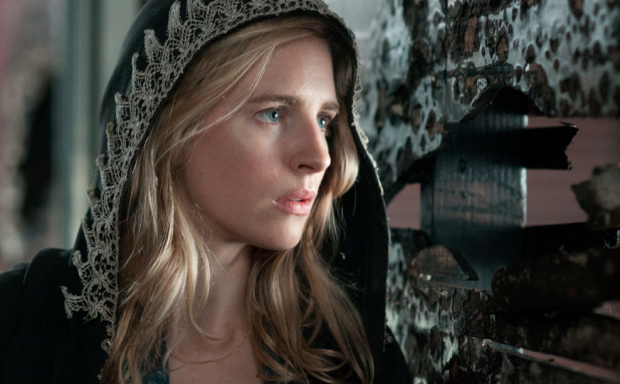Imagine this scene as part of a fantasy world. What role might this woman play? In a fantasy world, this woman could be a seer or a sorceress, tasked with guarding ancient secrets and predicting future events. Her black cloak, adorned with intricate lace, might be a garment of power, enabling her to access mystical planes or communicate with ethereal beings. The scene suggests she is on the brink of a significant revelation, perhaps about to uncover a prophecy that could alter the fate of her land. Her role would likely involve striking a balance between the knowledge of the past and the demands of the present, guiding her people through times of uncertainty and change. What kind of fantasy realm does she live in? She resides in a fantasy realm where magic and reality intertwine seamlessly. This world, called Eldoria, is filled with enchanted forests, ancient ruins, and towering castles. The skies shift colors with the changing moods of the realm, and mystical creatures roam freely. Eldoria is a land of both beauty and peril, where the past has a tangible presence, often influencing the present. The realm is governed by an intricate web of alliances and rivalries among diverse factions, each vying for control over powerful magical artifacts and ancient knowledge. In this world, our character stands as a beacon of wisdom and resilience, navigating through the complexities with her keen insight and formidable abilities. 